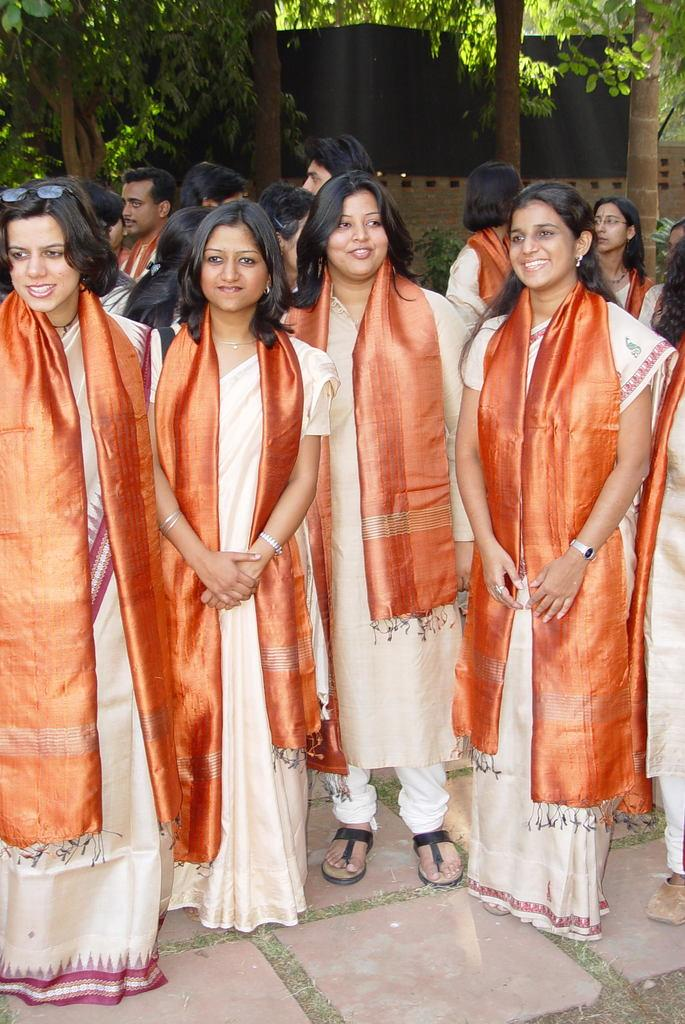How many people are present in the image? There are people in the image, but the exact number is not specified. What type of clothing accessories can be seen on some people? Some people are wearing shawls and glasses. What can be seen in the background of the image? There are trees, a wall, and a board in the background of the image. What is visible at the bottom of the image? There is ground visible at the bottom of the image. What type of quiver can be seen on the people in the image? There is no quiver present in the image; it features people wearing shawls and glasses. How does the board show the answers in the image? The board does not show any answers in the image; it is simply a part of the background. 